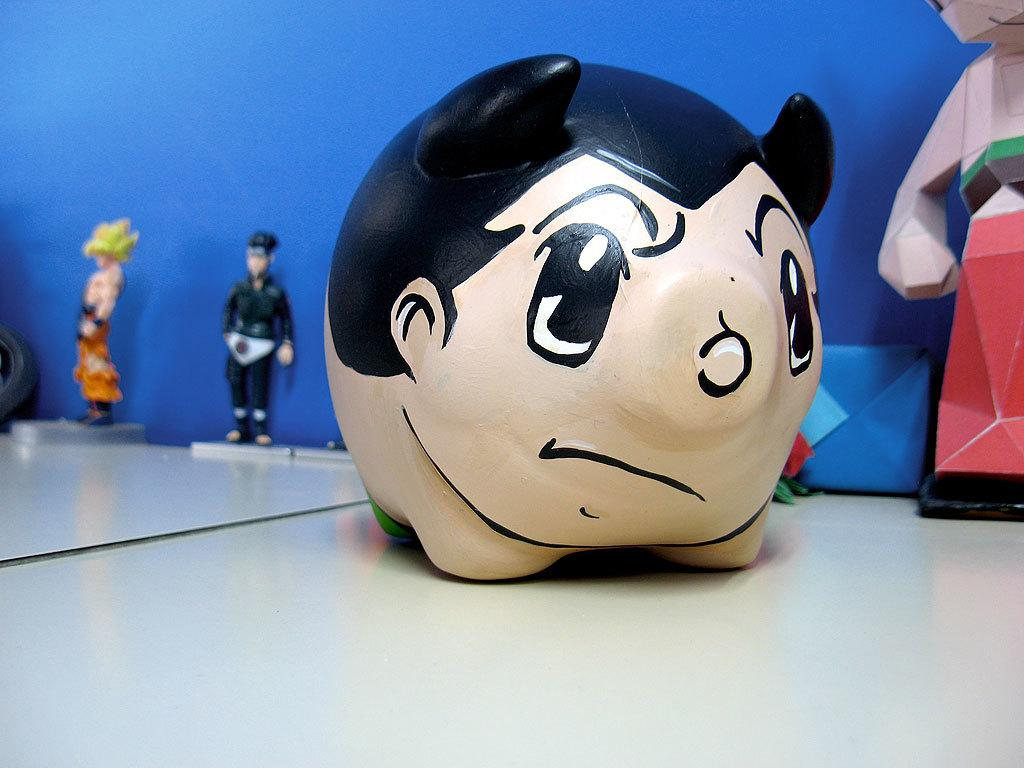What objects are on the table in the image? There are idols and toys on the table in the image. What color is the wall behind the table? There is a blue wall behind the table in the image. Where is the cable plugged in on the table in the image? There is no cable present in the image. What type of wax is being used to create the idols in the image? The idols in the image are not made of wax, and there is no wax present. 